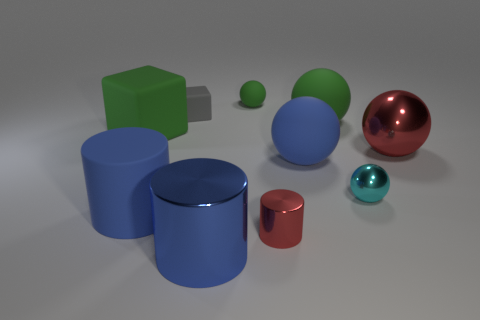What number of things are either large things or metallic things?
Your answer should be compact. 8. There is a tiny gray block on the left side of the green sphere that is right of the big blue sphere; what is it made of?
Keep it short and to the point. Rubber. How many large green things have the same shape as the small green rubber thing?
Offer a very short reply. 1. Are there any small metal cylinders of the same color as the large metallic sphere?
Your answer should be compact. Yes. How many objects are either matte things that are to the left of the tiny gray matte object or red metallic things that are left of the big red ball?
Give a very brief answer. 3. There is a green thing behind the tiny gray cube; are there any blue shiny objects that are behind it?
Make the answer very short. No. There is a red thing that is the same size as the cyan shiny sphere; what shape is it?
Keep it short and to the point. Cylinder. How many objects are large green matte things that are right of the big blue sphere or red things?
Offer a terse response. 3. What number of other things are made of the same material as the large blue sphere?
Keep it short and to the point. 5. There is a object that is the same color as the small cylinder; what shape is it?
Make the answer very short. Sphere. 